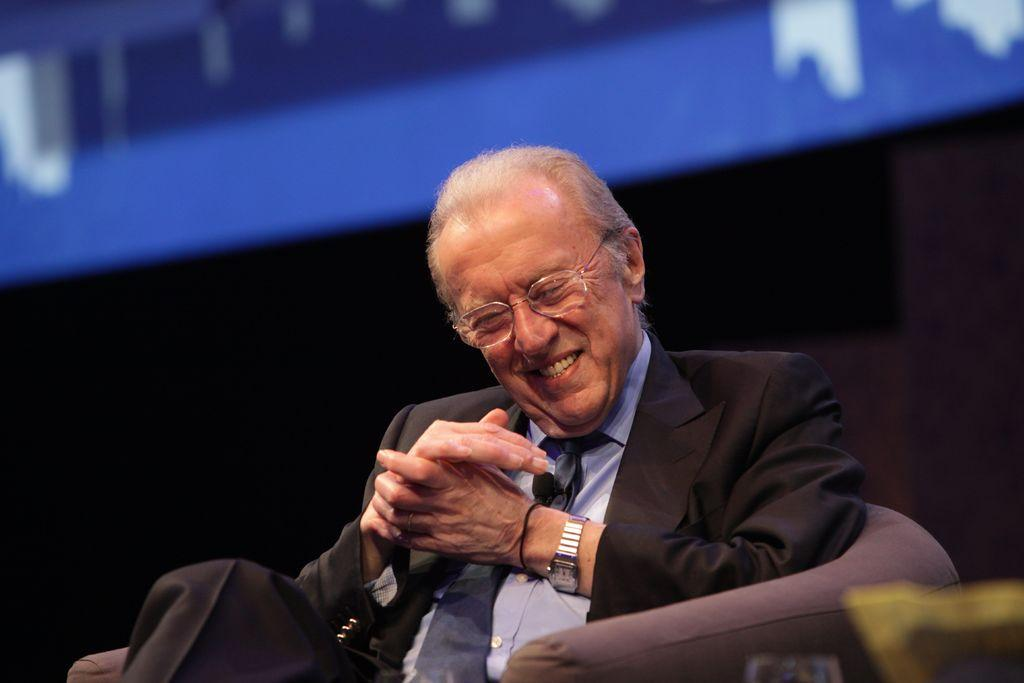What is the person in the image doing? The person is sitting on a chair and laughing. Can you describe the background of the image? The background of the image is blurry. How many tomatoes are being traded in the image? There are no tomatoes or any indication of trading in the image. 